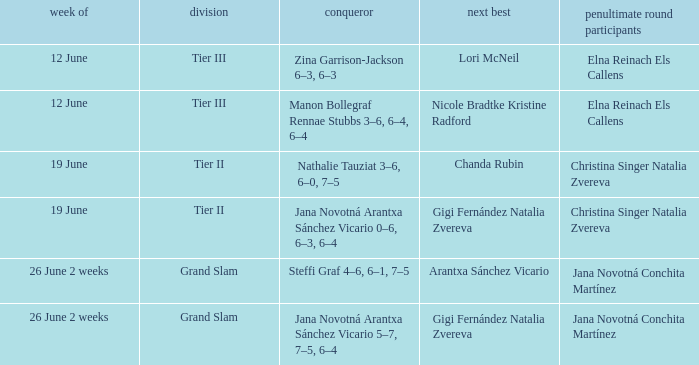In which week is the winner listed as Jana Novotná Arantxa Sánchez Vicario 5–7, 7–5, 6–4? 26 June 2 weeks. 